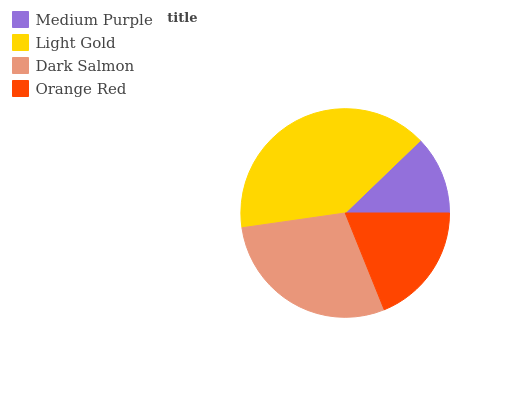Is Medium Purple the minimum?
Answer yes or no. Yes. Is Light Gold the maximum?
Answer yes or no. Yes. Is Dark Salmon the minimum?
Answer yes or no. No. Is Dark Salmon the maximum?
Answer yes or no. No. Is Light Gold greater than Dark Salmon?
Answer yes or no. Yes. Is Dark Salmon less than Light Gold?
Answer yes or no. Yes. Is Dark Salmon greater than Light Gold?
Answer yes or no. No. Is Light Gold less than Dark Salmon?
Answer yes or no. No. Is Dark Salmon the high median?
Answer yes or no. Yes. Is Orange Red the low median?
Answer yes or no. Yes. Is Light Gold the high median?
Answer yes or no. No. Is Medium Purple the low median?
Answer yes or no. No. 